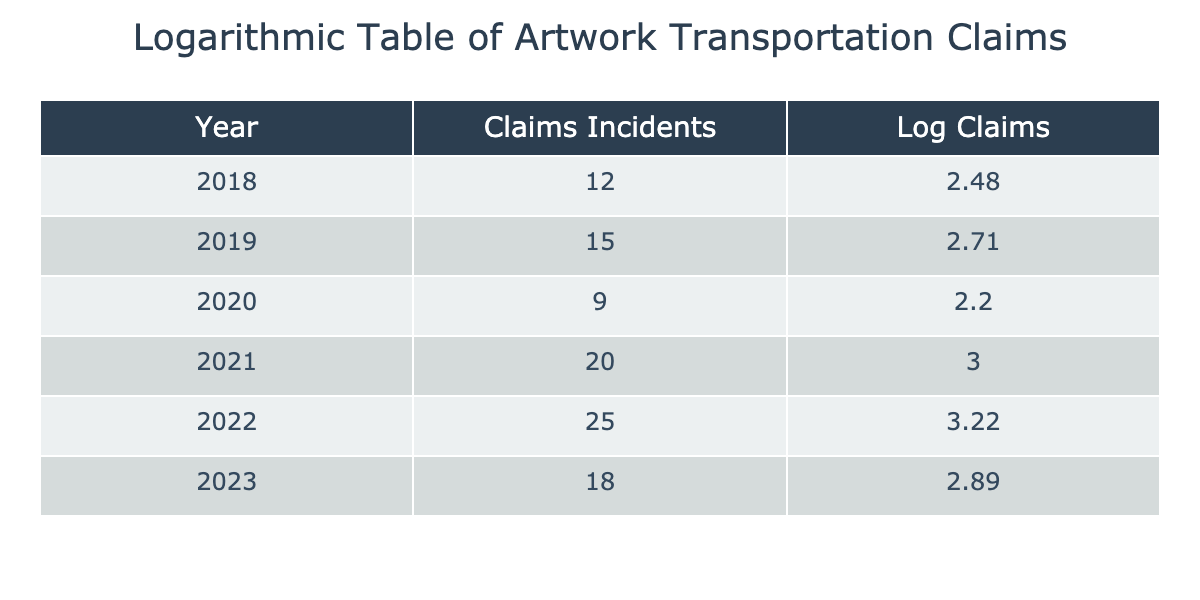What was the highest number of claims incidents in a single year? Looking at the "Claims Incidents" column, we can see the highest value is 25, which corresponds to the year 2022.
Answer: 25 In which year did the claims incidents decrease compared to the previous year? If we compare each row's "Claims Incidents" with the previous year's data, we find that the incidents decreased from 25 in 2022 to 18 in 2023.
Answer: 2023 What is the average number of claims incidents from 2018 to 2023? To find the average, we sum the claims: 12 + 15 + 9 + 20 + 25 + 18 = 99. Dividing by the number of years (6), we get 99/6 = 16.5.
Answer: 16.5 Was there a year where the claims incidents were less than 10? Looking through the table, all values in the "Claims Incidents" column are above 9; hence, there was no year with incidents less than 10.
Answer: No Which year experienced the most significant increase in claims incidents from the previous year? By examining the annual claims incidents, the largest jump occurred from 2020 (9 incidents) to 2021 (20 incidents), which is an increase of 11.
Answer: 2021 What was the total number of claims incidents from 2018 to 2023? Summing across all the years provides the total: 12 + 15 + 9 + 20 + 25 + 18 = 99.
Answer: 99 Is it true that the number of claims incidents increased every year from 2018 to 2022? Looking at the "Claims Incidents" data, we see that while there were increases from 2018 to 2021, 2022 saw another increase from 2021 (20) to 2022 (25), and compared to 2023, the value decreased. So, it is not true that it increased every year.
Answer: No Calculate the difference in claims incidents between the highest and lowest years from the table. The highest number of claims incidents is 25 (2022), and the lowest is 9 (2020). The difference is 25 - 9 = 16.
Answer: 16 